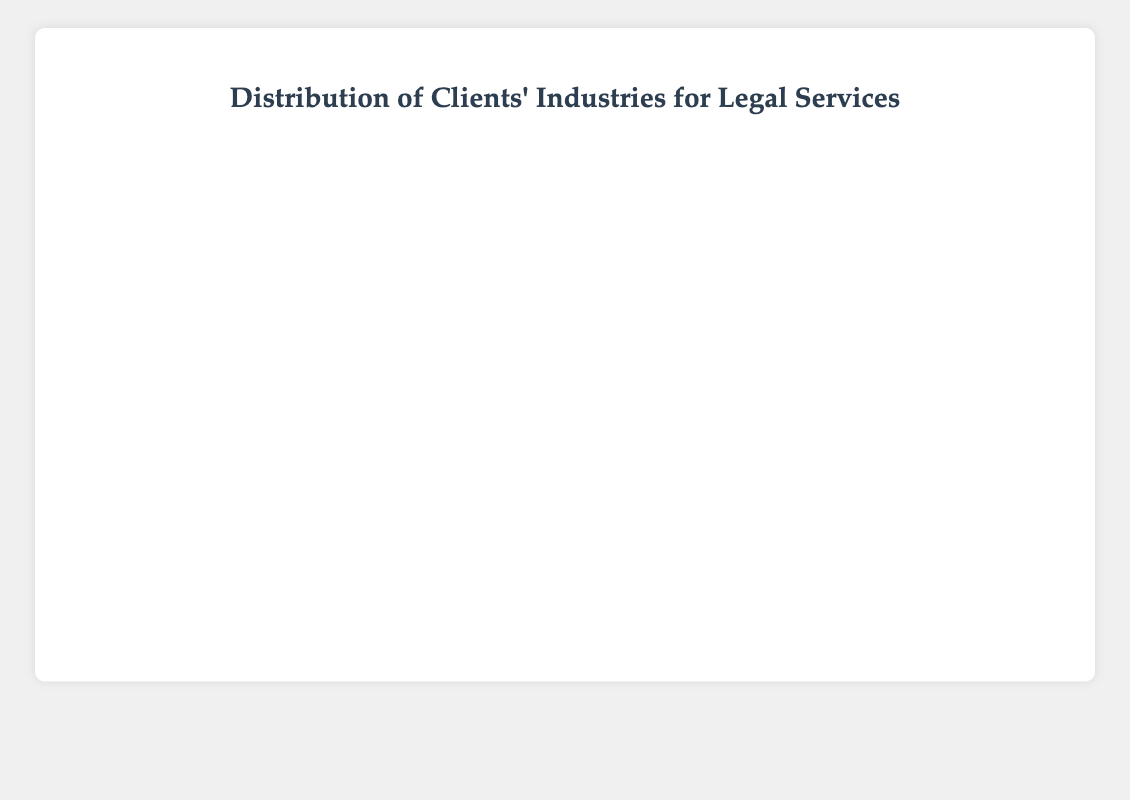Which industry has the highest number of cases represented? Look at the length of the bars to find the longest one, which corresponds to the highest number of cases. The "Healthcare" industry has the longest bar.
Answer: Healthcare How many more cases does the "Healthcare" industry have compared to "Real Estate"? Identify the lengths of the bars for "Healthcare" (120) and "Real Estate" (75). The difference is 120 - 75 = 45.
Answer: 45 What is the average number of cases represented across all industries? Sum up all the cases: 120 + 95 + 85 + 75 + 70 + 60 + 50 + 45 + 40 + 35 = 675. Then divide by the number of industries, which is 10. So, the average is 675 / 10 = 67.5.
Answer: 67.5 Which industries have fewer than 50 cases represented? Find the bars with lengths corresponding to fewer than 50 cases. These are "Energy" (50), "Entertainment" (45), "Transportation" (40), and "Hospitality" (35).
Answer: Entertainment, Transportation, Hospitality Is the number of cases in "Technology" greater than the sum of cases in "Energy" and "Transportation"? Compare the bar lengths: "Technology" has 95 cases, "Energy" has 50, and "Transportation" has 40. Sum of "Energy" and "Transportation" is 50 + 40 = 90. Since 95 > 90, "Technology" has more cases.
Answer: Yes Which industry represents the median value of cases? Order the number of cases in ascending order: 35, 40, 45, 50, 60, 70, 75, 85, 95, 120. The median is the middle value (5th and 6th): (60 + 70) / 2 = 65. The closest industry is Retail (60).
Answer: Retail How many industries have more than 70 cases represented? Count the bars with lengths greater than 70: "Healthcare" (120), "Technology" (95), "Financial Services" (85), "Real Estate" (75). There are 4 such industries.
Answer: 4 What is the difference between the number of cases in "Manufacturing" and "Retail"? Identify the lengths of the bars: "Manufacturing" (70) and "Retail" (60). The difference is 70 - 60 = 10.
Answer: 10 